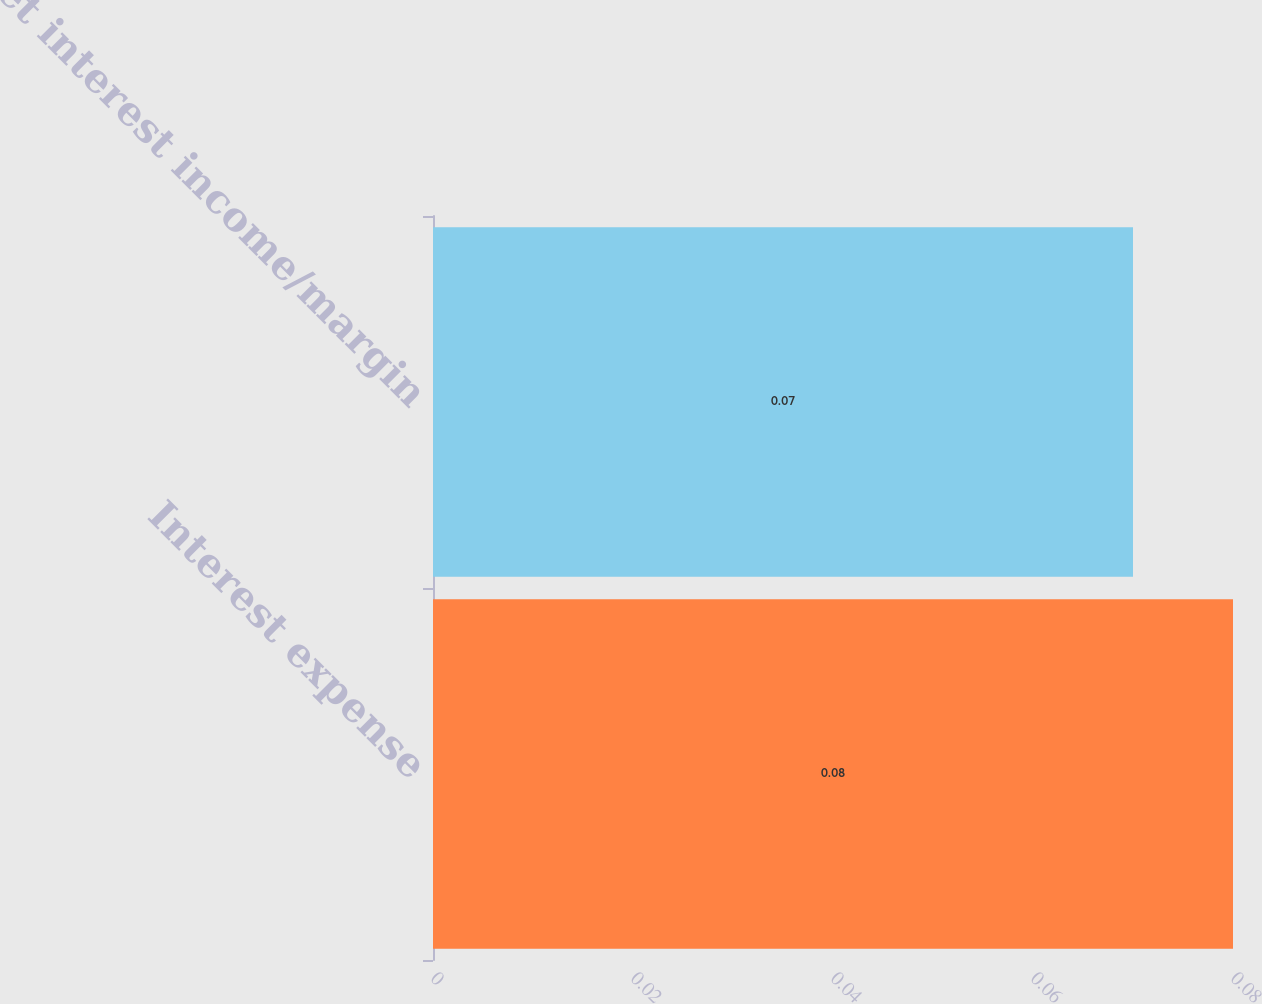Convert chart to OTSL. <chart><loc_0><loc_0><loc_500><loc_500><bar_chart><fcel>Interest expense<fcel>Net interest income/margin<nl><fcel>0.08<fcel>0.07<nl></chart> 